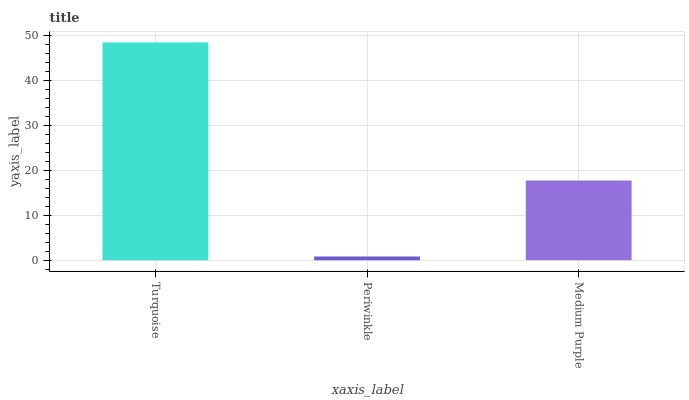Is Medium Purple the minimum?
Answer yes or no. No. Is Medium Purple the maximum?
Answer yes or no. No. Is Medium Purple greater than Periwinkle?
Answer yes or no. Yes. Is Periwinkle less than Medium Purple?
Answer yes or no. Yes. Is Periwinkle greater than Medium Purple?
Answer yes or no. No. Is Medium Purple less than Periwinkle?
Answer yes or no. No. Is Medium Purple the high median?
Answer yes or no. Yes. Is Medium Purple the low median?
Answer yes or no. Yes. Is Periwinkle the high median?
Answer yes or no. No. Is Turquoise the low median?
Answer yes or no. No. 